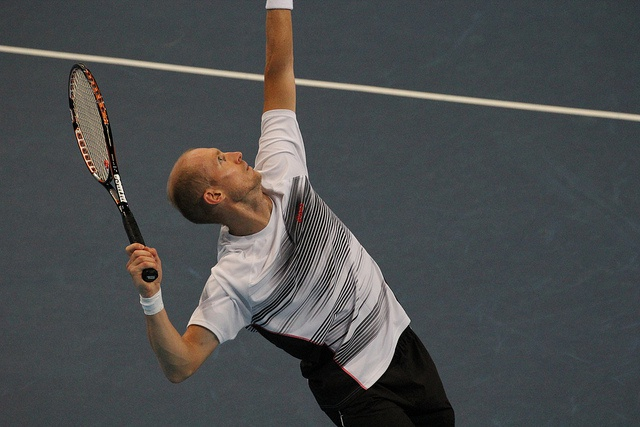Describe the objects in this image and their specific colors. I can see people in black, darkgray, and gray tones and tennis racket in black and gray tones in this image. 